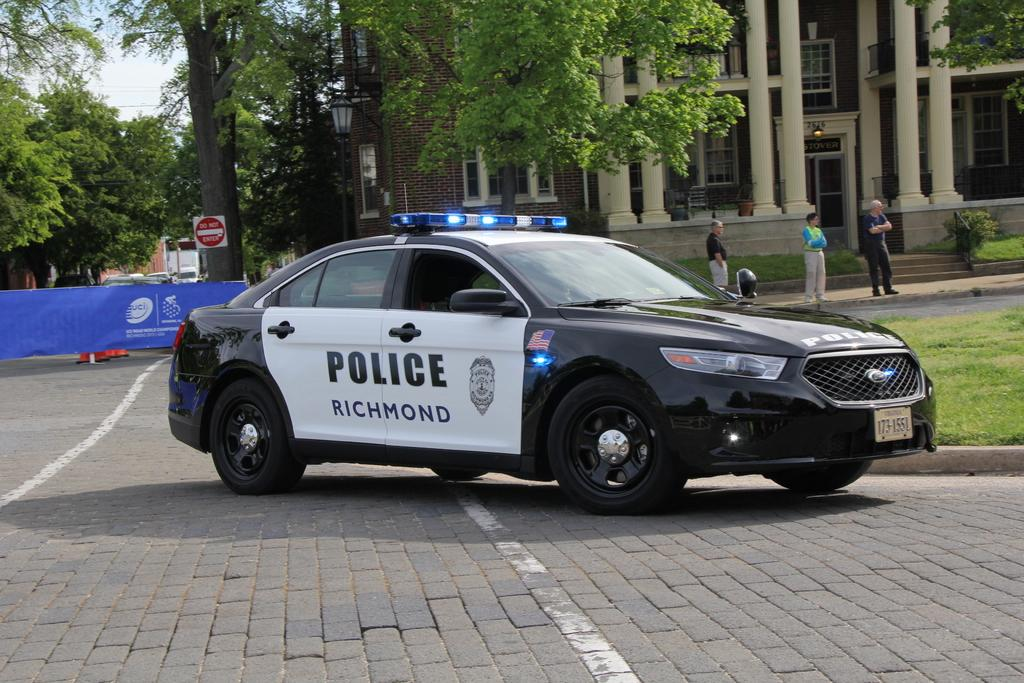What is the main subject of the image? The main subject of the image is a car on a pavement. What can be seen in the background of the image? In the background of the image, there are people, a building, trees, and a board with logos. Can you describe the setting of the image? The image appears to be set in an urban environment, with a car parked on a pavement and various buildings and trees visible in the background. What type of insurance policy is being discussed by the people in the image? There is no indication in the image that the people are discussing any insurance policies. 